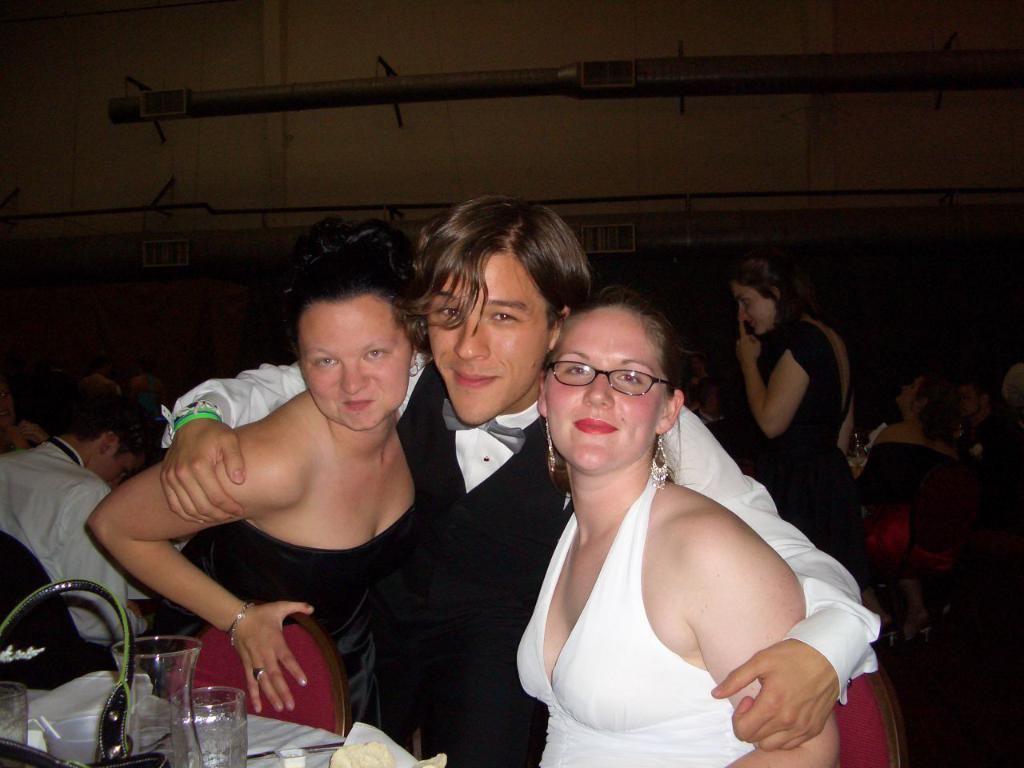How many people are visible in the image? There are many people in the image. What type of furniture is present in the image? There are tables and chairs in the image. What can be found on the tables in the image? There are jugs and glasses on the tables. What is the background of the image? There is a wall in the image. What type of pen is being used by the person in the image? There is no pen visible in the image. How does the person in the image express their feelings of hate towards someone or something? The image does not show any expressions of hate; it only depicts people, tables, chairs, jugs, glasses, and a wall. 